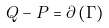Convert formula to latex. <formula><loc_0><loc_0><loc_500><loc_500>Q - P = \partial \left ( \Gamma \right )</formula> 